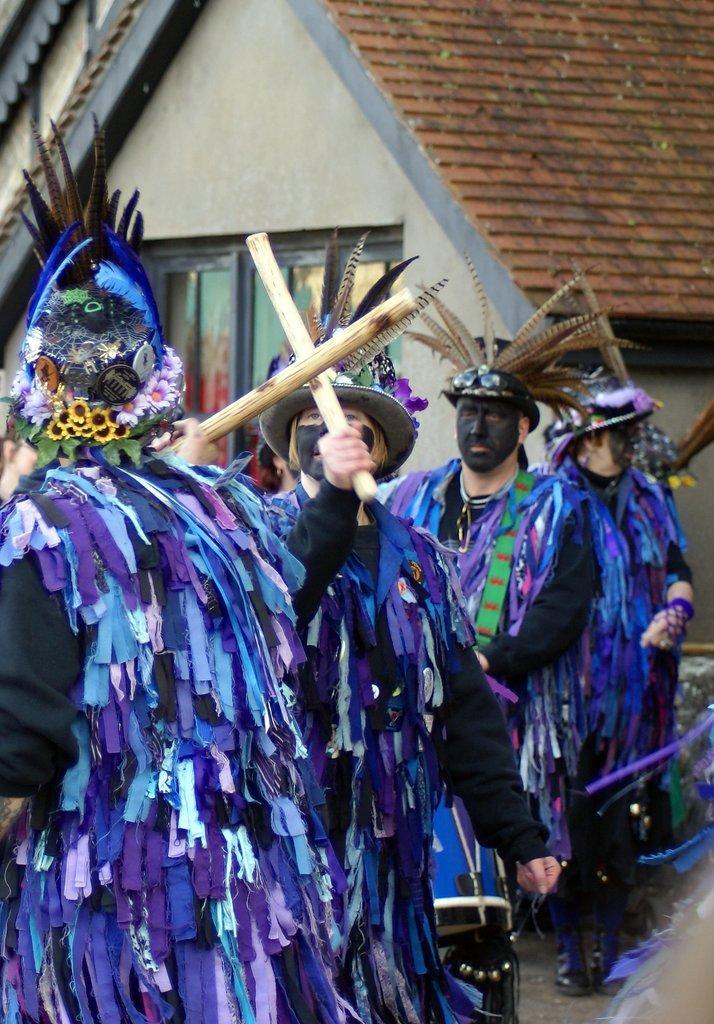How would you summarize this image in a sentence or two? Here few people are standing and playing with the sticks. They wore blue color clothes. This is a house. 